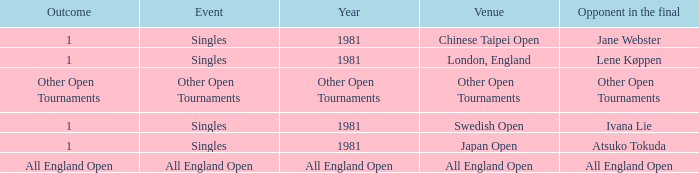What is the Outcome when All England Open is the Opponent in the final? All England Open. 